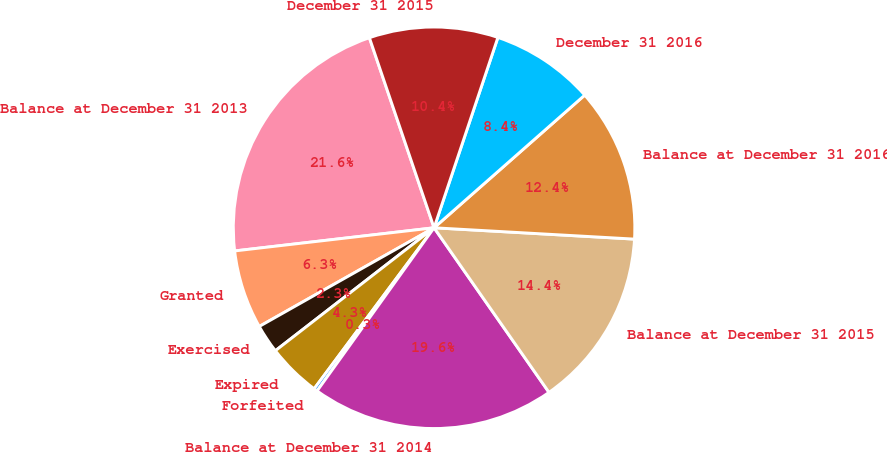Convert chart. <chart><loc_0><loc_0><loc_500><loc_500><pie_chart><fcel>Balance at December 31 2013<fcel>Granted<fcel>Exercised<fcel>Expired<fcel>Forfeited<fcel>Balance at December 31 2014<fcel>Balance at December 31 2015<fcel>Balance at December 31 2016<fcel>December 31 2016<fcel>December 31 2015<nl><fcel>21.62%<fcel>6.34%<fcel>2.31%<fcel>4.32%<fcel>0.29%<fcel>19.6%<fcel>14.4%<fcel>12.39%<fcel>8.36%<fcel>10.37%<nl></chart> 